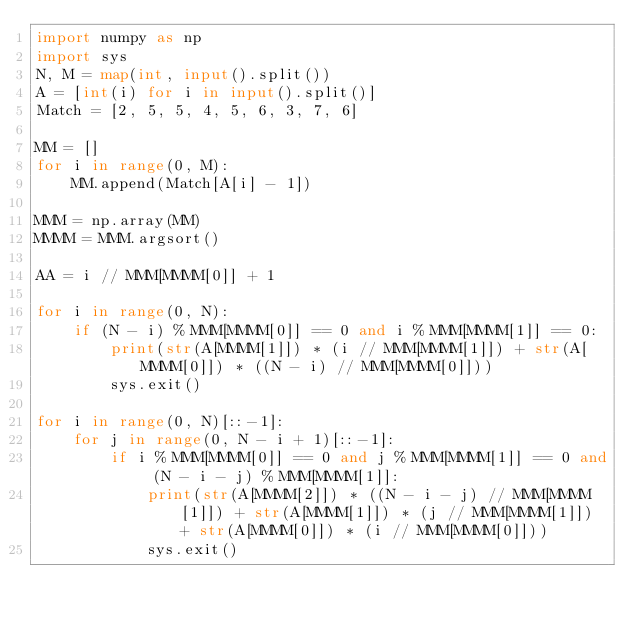<code> <loc_0><loc_0><loc_500><loc_500><_Python_>import numpy as np
import sys
N, M = map(int, input().split())
A = [int(i) for i in input().split()]
Match = [2, 5, 5, 4, 5, 6, 3, 7, 6]

MM = []
for i in range(0, M):
    MM.append(Match[A[i] - 1])

MMM = np.array(MM)
MMMM = MMM.argsort()

AA = i // MMM[MMMM[0]] + 1

for i in range(0, N):
    if (N - i) % MMM[MMMM[0]] == 0 and i % MMM[MMMM[1]] == 0:
        print(str(A[MMMM[1]]) * (i // MMM[MMMM[1]]) + str(A[MMMM[0]]) * ((N - i) // MMM[MMMM[0]]))
        sys.exit()

for i in range(0, N)[::-1]:
    for j in range(0, N - i + 1)[::-1]:
        if i % MMM[MMMM[0]] == 0 and j % MMM[MMMM[1]] == 0 and (N - i - j) % MMM[MMMM[1]]:
            print(str(A[MMMM[2]]) * ((N - i - j) // MMM[MMMM[1]]) + str(A[MMMM[1]]) * (j // MMM[MMMM[1]]) + str(A[MMMM[0]]) * (i // MMM[MMMM[0]]))
            sys.exit()</code> 